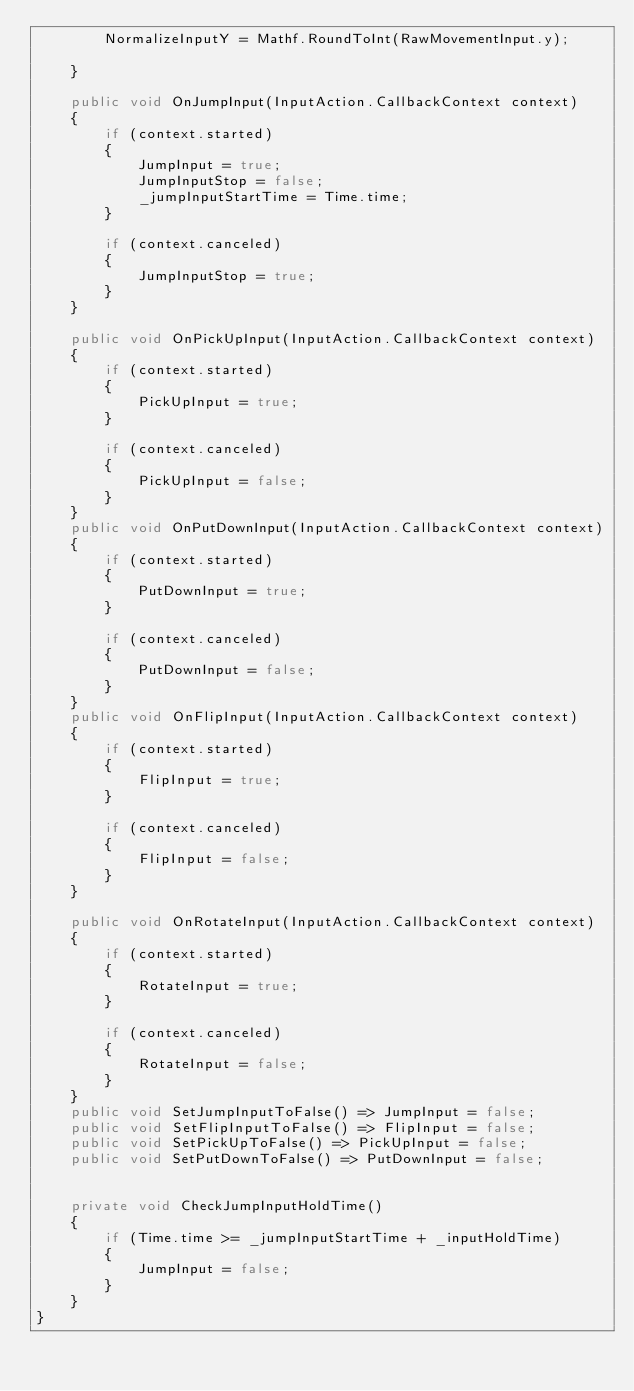Convert code to text. <code><loc_0><loc_0><loc_500><loc_500><_C#_>        NormalizeInputY = Mathf.RoundToInt(RawMovementInput.y);

    }

    public void OnJumpInput(InputAction.CallbackContext context)
    {
        if (context.started)
        {
            JumpInput = true;
            JumpInputStop = false;
            _jumpInputStartTime = Time.time;
        }

        if (context.canceled)
        {
            JumpInputStop = true;
        }
    }

    public void OnPickUpInput(InputAction.CallbackContext context)
    {
        if (context.started)
        {
            PickUpInput = true;
        }

        if (context.canceled)
        {
            PickUpInput = false;
        }
    }
    public void OnPutDownInput(InputAction.CallbackContext context)
    {
        if (context.started)
        {
            PutDownInput = true;
        }

        if (context.canceled)
        {
            PutDownInput = false;
        }
    }
    public void OnFlipInput(InputAction.CallbackContext context)
    {
        if (context.started)
        {
            FlipInput = true;
        }

        if (context.canceled)
        {
            FlipInput = false;
        }
    }

    public void OnRotateInput(InputAction.CallbackContext context)
    {
        if (context.started)
        {
            RotateInput = true;
        }

        if (context.canceled)
        {
            RotateInput = false;
        }
    }
    public void SetJumpInputToFalse() => JumpInput = false;
    public void SetFlipInputToFalse() => FlipInput = false;
    public void SetPickUpToFalse() => PickUpInput = false;
    public void SetPutDownToFalse() => PutDownInput = false;


    private void CheckJumpInputHoldTime()
    {
        if (Time.time >= _jumpInputStartTime + _inputHoldTime)
        {
            JumpInput = false;
        }
    }
}
</code> 